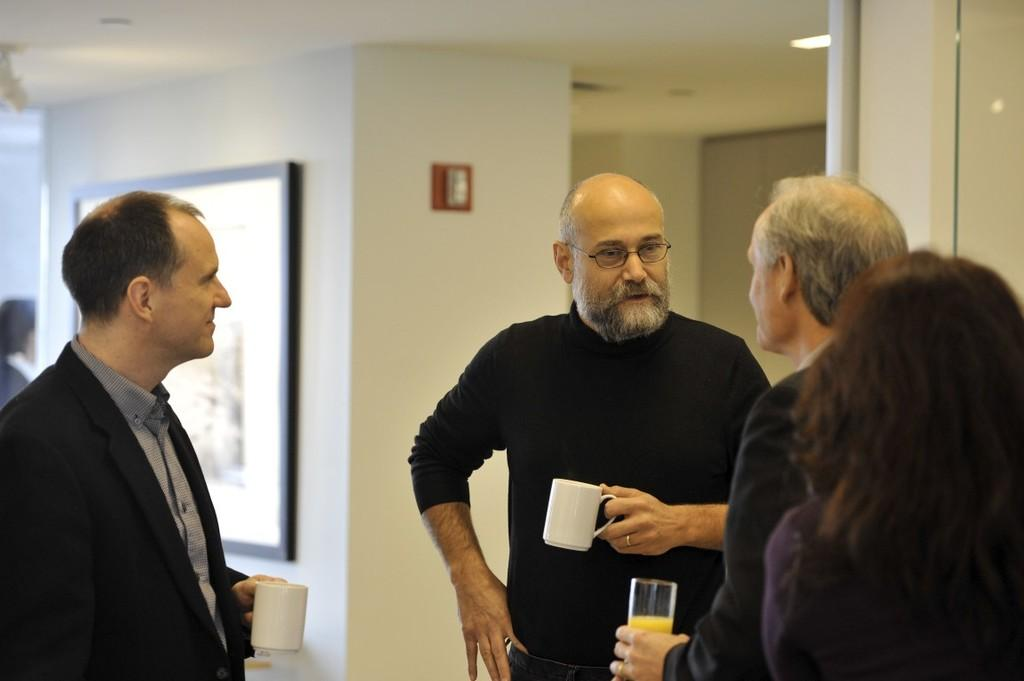What are the people in the image doing? The people in the image are standing and holding cups and glasses. What might be in the cups and glasses they are holding? It is not clear from the image what is in the cups and glasses, but they are likely holding beverages. What can be seen on the wall in the background? There is a frame attached to the wall in the background. What is visible at the top of the image? Lights are visible at the top of the image. How many beggars are present in the image? There are no beggars present in the image; it features people holding cups and glasses. What type of volcano can be seen erupting in the background of the image? There is no volcano present in the image; it features a frame on the wall in the background. 